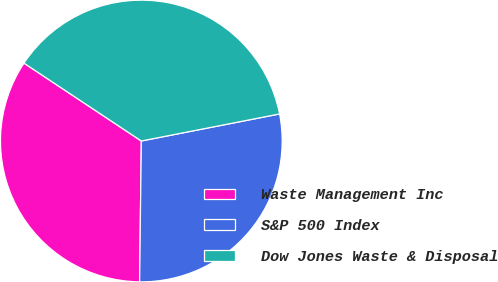Convert chart to OTSL. <chart><loc_0><loc_0><loc_500><loc_500><pie_chart><fcel>Waste Management Inc<fcel>S&P 500 Index<fcel>Dow Jones Waste & Disposal<nl><fcel>34.13%<fcel>28.27%<fcel>37.6%<nl></chart> 